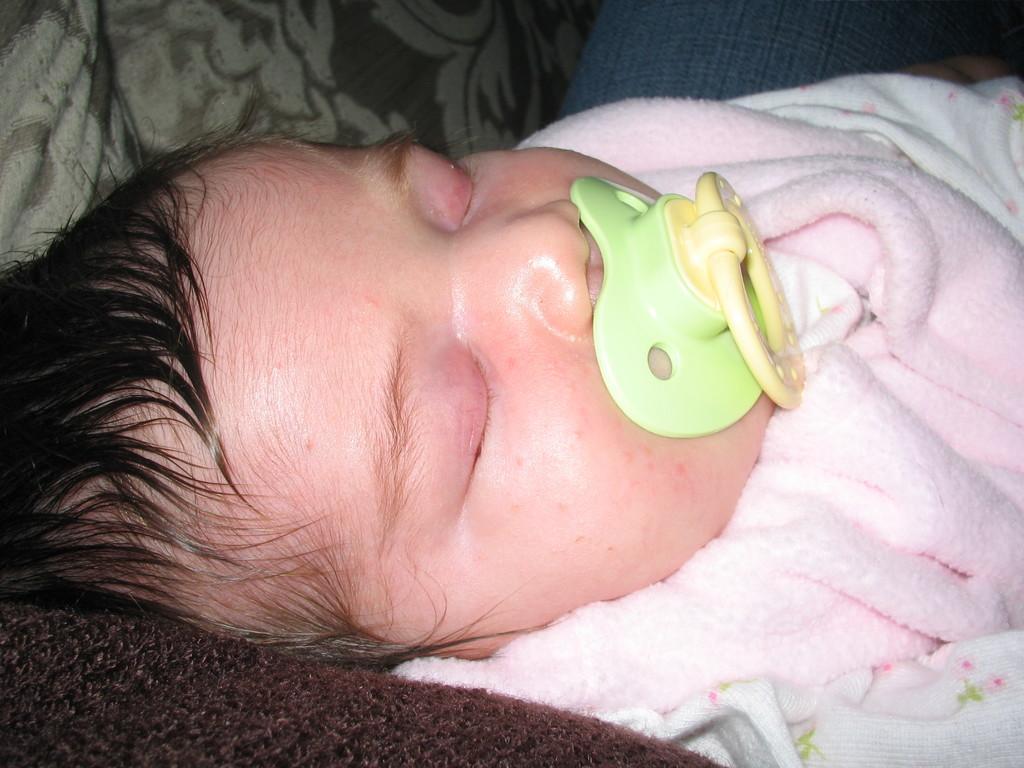Could you give a brief overview of what you see in this image? There is an infant sleeping and there is a pacifier in the infant's mouth,the baby is wrapped in a pink cloth. 